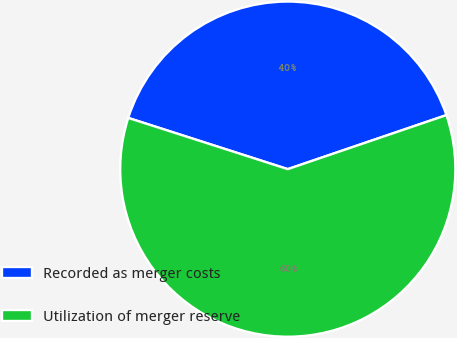<chart> <loc_0><loc_0><loc_500><loc_500><pie_chart><fcel>Recorded as merger costs<fcel>Utilization of merger reserve<nl><fcel>39.83%<fcel>60.17%<nl></chart> 